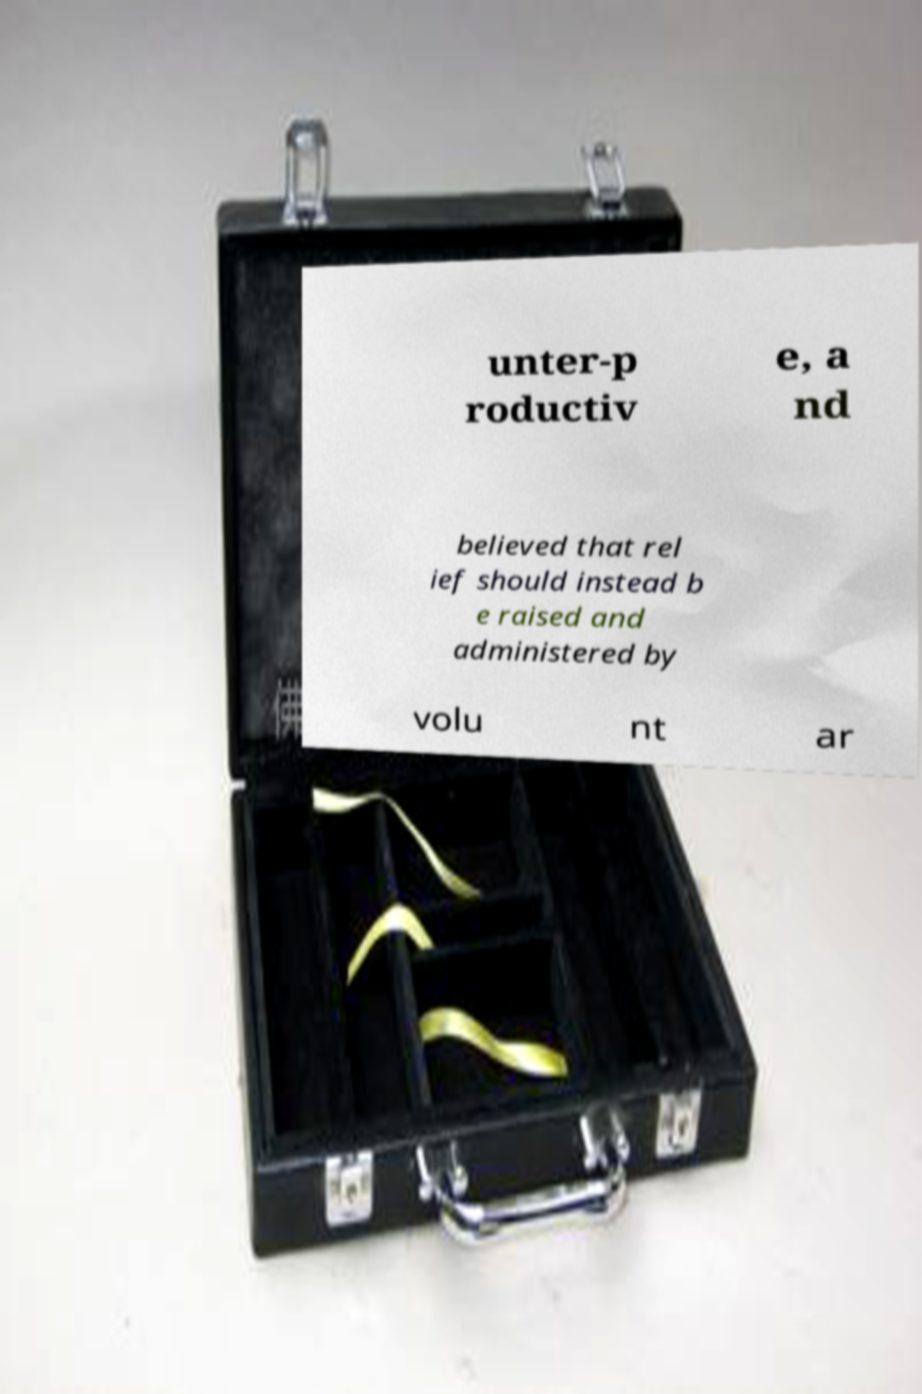I need the written content from this picture converted into text. Can you do that? unter-p roductiv e, a nd believed that rel ief should instead b e raised and administered by volu nt ar 